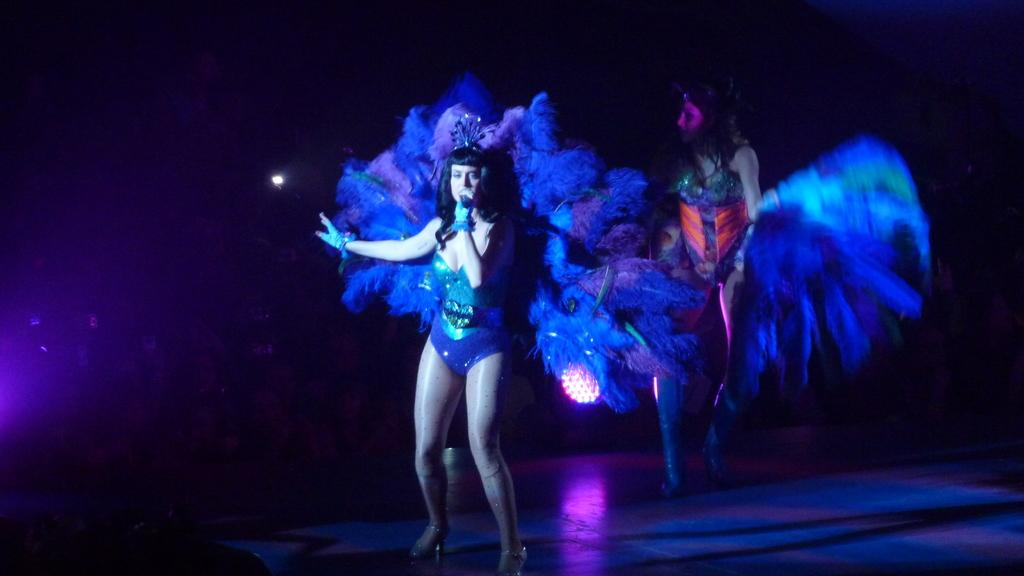How many people are in the image? There are two women in the image. Where are the women located in the image? The women are standing on a stage. What are the women wearing? The women are wearing costumes. What is one of the women holding? One of the women is holding a mic. How many bikes are visible in the image? There are no bikes present in the image. What type of tooth is being exchanged between the women in the image? There is no tooth exchange happening in the image; the women are wearing costumes and one is holding a mic. 